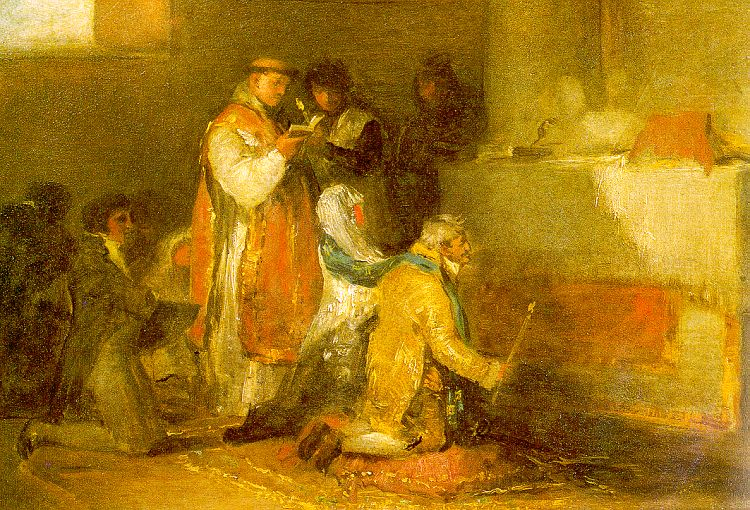Briefly describe what might be happening in this image. This image likely depicts a small group engaged in a prayer or reading session, set in a room bathed in warm light. The central figures, dressed in robes, suggest a religious or meditative context, with activities such as reading and kneeling indicating a moment of reflection or devotion. 